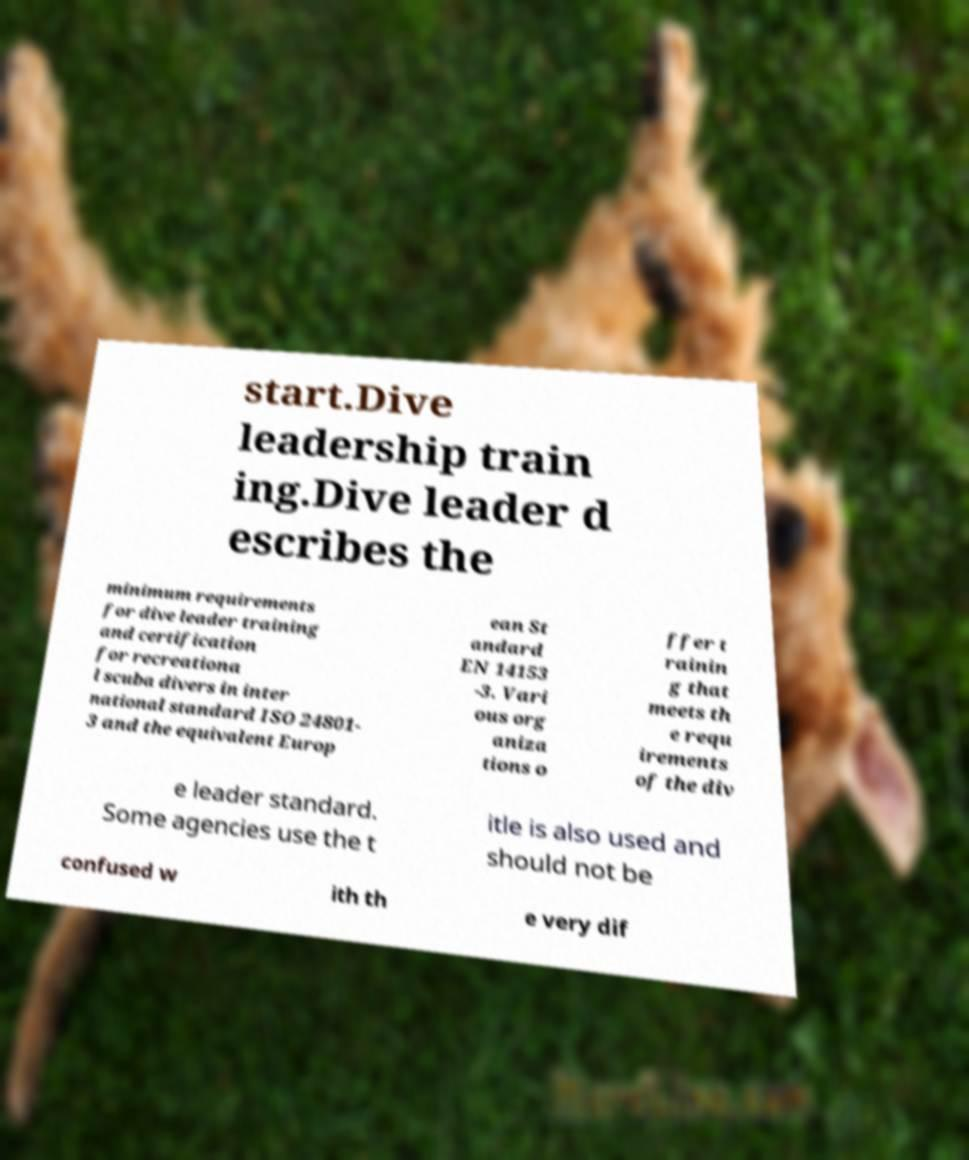Can you accurately transcribe the text from the provided image for me? start.Dive leadership train ing.Dive leader d escribes the minimum requirements for dive leader training and certification for recreationa l scuba divers in inter national standard ISO 24801- 3 and the equivalent Europ ean St andard EN 14153 -3. Vari ous org aniza tions o ffer t rainin g that meets th e requ irements of the div e leader standard. Some agencies use the t itle is also used and should not be confused w ith th e very dif 